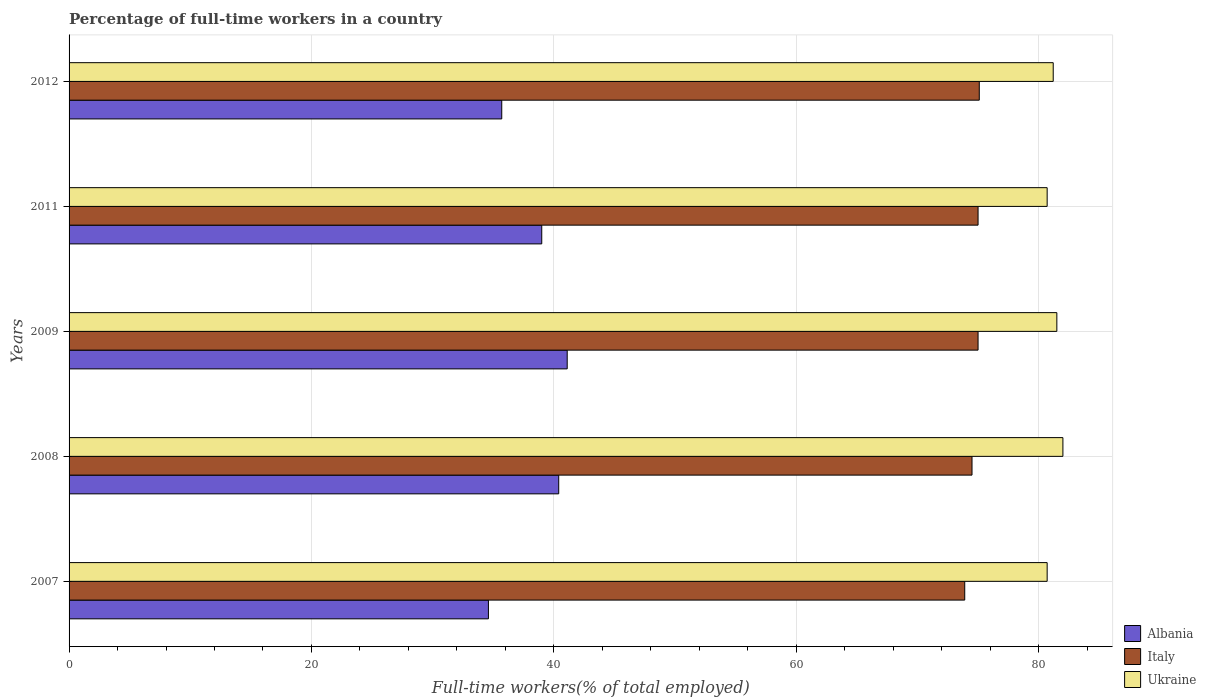How many different coloured bars are there?
Make the answer very short. 3. How many groups of bars are there?
Ensure brevity in your answer.  5. How many bars are there on the 4th tick from the top?
Provide a succinct answer. 3. What is the label of the 5th group of bars from the top?
Ensure brevity in your answer.  2007. In how many cases, is the number of bars for a given year not equal to the number of legend labels?
Provide a succinct answer. 0. What is the percentage of full-time workers in Ukraine in 2011?
Keep it short and to the point. 80.7. Across all years, what is the maximum percentage of full-time workers in Ukraine?
Give a very brief answer. 82. Across all years, what is the minimum percentage of full-time workers in Ukraine?
Ensure brevity in your answer.  80.7. What is the total percentage of full-time workers in Albania in the graph?
Your response must be concise. 190.8. What is the difference between the percentage of full-time workers in Albania in 2007 and that in 2009?
Your response must be concise. -6.5. What is the difference between the percentage of full-time workers in Italy in 2008 and the percentage of full-time workers in Ukraine in 2012?
Give a very brief answer. -6.7. What is the average percentage of full-time workers in Italy per year?
Your response must be concise. 74.7. Is the difference between the percentage of full-time workers in Italy in 2008 and 2011 greater than the difference between the percentage of full-time workers in Albania in 2008 and 2011?
Your answer should be compact. No. What is the difference between the highest and the second highest percentage of full-time workers in Albania?
Your answer should be very brief. 0.7. What is the difference between the highest and the lowest percentage of full-time workers in Ukraine?
Make the answer very short. 1.3. What does the 1st bar from the top in 2012 represents?
Give a very brief answer. Ukraine. Are all the bars in the graph horizontal?
Your response must be concise. Yes. Are the values on the major ticks of X-axis written in scientific E-notation?
Give a very brief answer. No. Does the graph contain any zero values?
Your answer should be very brief. No. Does the graph contain grids?
Your response must be concise. Yes. Where does the legend appear in the graph?
Your response must be concise. Bottom right. How are the legend labels stacked?
Your answer should be very brief. Vertical. What is the title of the graph?
Keep it short and to the point. Percentage of full-time workers in a country. What is the label or title of the X-axis?
Offer a terse response. Full-time workers(% of total employed). What is the label or title of the Y-axis?
Offer a very short reply. Years. What is the Full-time workers(% of total employed) in Albania in 2007?
Provide a short and direct response. 34.6. What is the Full-time workers(% of total employed) in Italy in 2007?
Your answer should be compact. 73.9. What is the Full-time workers(% of total employed) in Ukraine in 2007?
Offer a terse response. 80.7. What is the Full-time workers(% of total employed) of Albania in 2008?
Provide a short and direct response. 40.4. What is the Full-time workers(% of total employed) of Italy in 2008?
Ensure brevity in your answer.  74.5. What is the Full-time workers(% of total employed) of Ukraine in 2008?
Offer a terse response. 82. What is the Full-time workers(% of total employed) of Albania in 2009?
Keep it short and to the point. 41.1. What is the Full-time workers(% of total employed) of Italy in 2009?
Your answer should be compact. 75. What is the Full-time workers(% of total employed) of Ukraine in 2009?
Your response must be concise. 81.5. What is the Full-time workers(% of total employed) of Italy in 2011?
Give a very brief answer. 75. What is the Full-time workers(% of total employed) of Ukraine in 2011?
Your answer should be compact. 80.7. What is the Full-time workers(% of total employed) of Albania in 2012?
Your response must be concise. 35.7. What is the Full-time workers(% of total employed) in Italy in 2012?
Offer a very short reply. 75.1. What is the Full-time workers(% of total employed) in Ukraine in 2012?
Offer a very short reply. 81.2. Across all years, what is the maximum Full-time workers(% of total employed) in Albania?
Keep it short and to the point. 41.1. Across all years, what is the maximum Full-time workers(% of total employed) in Italy?
Your answer should be compact. 75.1. Across all years, what is the maximum Full-time workers(% of total employed) of Ukraine?
Offer a terse response. 82. Across all years, what is the minimum Full-time workers(% of total employed) of Albania?
Offer a very short reply. 34.6. Across all years, what is the minimum Full-time workers(% of total employed) of Italy?
Ensure brevity in your answer.  73.9. Across all years, what is the minimum Full-time workers(% of total employed) in Ukraine?
Offer a very short reply. 80.7. What is the total Full-time workers(% of total employed) of Albania in the graph?
Provide a short and direct response. 190.8. What is the total Full-time workers(% of total employed) in Italy in the graph?
Your response must be concise. 373.5. What is the total Full-time workers(% of total employed) of Ukraine in the graph?
Provide a short and direct response. 406.1. What is the difference between the Full-time workers(% of total employed) in Albania in 2007 and that in 2008?
Your answer should be very brief. -5.8. What is the difference between the Full-time workers(% of total employed) of Italy in 2007 and that in 2008?
Keep it short and to the point. -0.6. What is the difference between the Full-time workers(% of total employed) of Italy in 2007 and that in 2009?
Give a very brief answer. -1.1. What is the difference between the Full-time workers(% of total employed) of Ukraine in 2007 and that in 2011?
Your answer should be very brief. 0. What is the difference between the Full-time workers(% of total employed) in Albania in 2008 and that in 2009?
Offer a very short reply. -0.7. What is the difference between the Full-time workers(% of total employed) of Ukraine in 2008 and that in 2009?
Your answer should be very brief. 0.5. What is the difference between the Full-time workers(% of total employed) of Italy in 2008 and that in 2011?
Provide a succinct answer. -0.5. What is the difference between the Full-time workers(% of total employed) in Ukraine in 2008 and that in 2011?
Your response must be concise. 1.3. What is the difference between the Full-time workers(% of total employed) of Italy in 2009 and that in 2011?
Keep it short and to the point. 0. What is the difference between the Full-time workers(% of total employed) of Ukraine in 2009 and that in 2011?
Your response must be concise. 0.8. What is the difference between the Full-time workers(% of total employed) in Albania in 2009 and that in 2012?
Your answer should be very brief. 5.4. What is the difference between the Full-time workers(% of total employed) in Ukraine in 2009 and that in 2012?
Make the answer very short. 0.3. What is the difference between the Full-time workers(% of total employed) in Albania in 2007 and the Full-time workers(% of total employed) in Italy in 2008?
Offer a terse response. -39.9. What is the difference between the Full-time workers(% of total employed) in Albania in 2007 and the Full-time workers(% of total employed) in Ukraine in 2008?
Your response must be concise. -47.4. What is the difference between the Full-time workers(% of total employed) of Italy in 2007 and the Full-time workers(% of total employed) of Ukraine in 2008?
Provide a short and direct response. -8.1. What is the difference between the Full-time workers(% of total employed) in Albania in 2007 and the Full-time workers(% of total employed) in Italy in 2009?
Offer a terse response. -40.4. What is the difference between the Full-time workers(% of total employed) of Albania in 2007 and the Full-time workers(% of total employed) of Ukraine in 2009?
Offer a terse response. -46.9. What is the difference between the Full-time workers(% of total employed) in Albania in 2007 and the Full-time workers(% of total employed) in Italy in 2011?
Your response must be concise. -40.4. What is the difference between the Full-time workers(% of total employed) in Albania in 2007 and the Full-time workers(% of total employed) in Ukraine in 2011?
Ensure brevity in your answer.  -46.1. What is the difference between the Full-time workers(% of total employed) of Italy in 2007 and the Full-time workers(% of total employed) of Ukraine in 2011?
Offer a very short reply. -6.8. What is the difference between the Full-time workers(% of total employed) of Albania in 2007 and the Full-time workers(% of total employed) of Italy in 2012?
Give a very brief answer. -40.5. What is the difference between the Full-time workers(% of total employed) in Albania in 2007 and the Full-time workers(% of total employed) in Ukraine in 2012?
Offer a terse response. -46.6. What is the difference between the Full-time workers(% of total employed) in Albania in 2008 and the Full-time workers(% of total employed) in Italy in 2009?
Offer a terse response. -34.6. What is the difference between the Full-time workers(% of total employed) in Albania in 2008 and the Full-time workers(% of total employed) in Ukraine in 2009?
Your answer should be compact. -41.1. What is the difference between the Full-time workers(% of total employed) in Italy in 2008 and the Full-time workers(% of total employed) in Ukraine in 2009?
Your response must be concise. -7. What is the difference between the Full-time workers(% of total employed) in Albania in 2008 and the Full-time workers(% of total employed) in Italy in 2011?
Your response must be concise. -34.6. What is the difference between the Full-time workers(% of total employed) in Albania in 2008 and the Full-time workers(% of total employed) in Ukraine in 2011?
Make the answer very short. -40.3. What is the difference between the Full-time workers(% of total employed) of Albania in 2008 and the Full-time workers(% of total employed) of Italy in 2012?
Keep it short and to the point. -34.7. What is the difference between the Full-time workers(% of total employed) of Albania in 2008 and the Full-time workers(% of total employed) of Ukraine in 2012?
Ensure brevity in your answer.  -40.8. What is the difference between the Full-time workers(% of total employed) in Albania in 2009 and the Full-time workers(% of total employed) in Italy in 2011?
Make the answer very short. -33.9. What is the difference between the Full-time workers(% of total employed) in Albania in 2009 and the Full-time workers(% of total employed) in Ukraine in 2011?
Offer a very short reply. -39.6. What is the difference between the Full-time workers(% of total employed) in Italy in 2009 and the Full-time workers(% of total employed) in Ukraine in 2011?
Ensure brevity in your answer.  -5.7. What is the difference between the Full-time workers(% of total employed) in Albania in 2009 and the Full-time workers(% of total employed) in Italy in 2012?
Your answer should be very brief. -34. What is the difference between the Full-time workers(% of total employed) of Albania in 2009 and the Full-time workers(% of total employed) of Ukraine in 2012?
Keep it short and to the point. -40.1. What is the difference between the Full-time workers(% of total employed) in Albania in 2011 and the Full-time workers(% of total employed) in Italy in 2012?
Provide a succinct answer. -36.1. What is the difference between the Full-time workers(% of total employed) of Albania in 2011 and the Full-time workers(% of total employed) of Ukraine in 2012?
Ensure brevity in your answer.  -42.2. What is the difference between the Full-time workers(% of total employed) in Italy in 2011 and the Full-time workers(% of total employed) in Ukraine in 2012?
Keep it short and to the point. -6.2. What is the average Full-time workers(% of total employed) of Albania per year?
Offer a terse response. 38.16. What is the average Full-time workers(% of total employed) of Italy per year?
Offer a very short reply. 74.7. What is the average Full-time workers(% of total employed) of Ukraine per year?
Give a very brief answer. 81.22. In the year 2007, what is the difference between the Full-time workers(% of total employed) in Albania and Full-time workers(% of total employed) in Italy?
Your answer should be compact. -39.3. In the year 2007, what is the difference between the Full-time workers(% of total employed) in Albania and Full-time workers(% of total employed) in Ukraine?
Make the answer very short. -46.1. In the year 2008, what is the difference between the Full-time workers(% of total employed) of Albania and Full-time workers(% of total employed) of Italy?
Offer a very short reply. -34.1. In the year 2008, what is the difference between the Full-time workers(% of total employed) in Albania and Full-time workers(% of total employed) in Ukraine?
Give a very brief answer. -41.6. In the year 2008, what is the difference between the Full-time workers(% of total employed) in Italy and Full-time workers(% of total employed) in Ukraine?
Your answer should be compact. -7.5. In the year 2009, what is the difference between the Full-time workers(% of total employed) in Albania and Full-time workers(% of total employed) in Italy?
Provide a succinct answer. -33.9. In the year 2009, what is the difference between the Full-time workers(% of total employed) of Albania and Full-time workers(% of total employed) of Ukraine?
Keep it short and to the point. -40.4. In the year 2011, what is the difference between the Full-time workers(% of total employed) of Albania and Full-time workers(% of total employed) of Italy?
Your answer should be very brief. -36. In the year 2011, what is the difference between the Full-time workers(% of total employed) of Albania and Full-time workers(% of total employed) of Ukraine?
Your answer should be compact. -41.7. In the year 2011, what is the difference between the Full-time workers(% of total employed) in Italy and Full-time workers(% of total employed) in Ukraine?
Your answer should be very brief. -5.7. In the year 2012, what is the difference between the Full-time workers(% of total employed) in Albania and Full-time workers(% of total employed) in Italy?
Your answer should be compact. -39.4. In the year 2012, what is the difference between the Full-time workers(% of total employed) of Albania and Full-time workers(% of total employed) of Ukraine?
Your answer should be compact. -45.5. In the year 2012, what is the difference between the Full-time workers(% of total employed) of Italy and Full-time workers(% of total employed) of Ukraine?
Your response must be concise. -6.1. What is the ratio of the Full-time workers(% of total employed) of Albania in 2007 to that in 2008?
Keep it short and to the point. 0.86. What is the ratio of the Full-time workers(% of total employed) in Ukraine in 2007 to that in 2008?
Provide a short and direct response. 0.98. What is the ratio of the Full-time workers(% of total employed) in Albania in 2007 to that in 2009?
Keep it short and to the point. 0.84. What is the ratio of the Full-time workers(% of total employed) in Italy in 2007 to that in 2009?
Make the answer very short. 0.99. What is the ratio of the Full-time workers(% of total employed) of Ukraine in 2007 to that in 2009?
Your response must be concise. 0.99. What is the ratio of the Full-time workers(% of total employed) in Albania in 2007 to that in 2011?
Provide a succinct answer. 0.89. What is the ratio of the Full-time workers(% of total employed) of Italy in 2007 to that in 2011?
Offer a terse response. 0.99. What is the ratio of the Full-time workers(% of total employed) in Ukraine in 2007 to that in 2011?
Offer a very short reply. 1. What is the ratio of the Full-time workers(% of total employed) in Albania in 2007 to that in 2012?
Offer a terse response. 0.97. What is the ratio of the Full-time workers(% of total employed) of Italy in 2007 to that in 2012?
Your response must be concise. 0.98. What is the ratio of the Full-time workers(% of total employed) of Ukraine in 2007 to that in 2012?
Your answer should be compact. 0.99. What is the ratio of the Full-time workers(% of total employed) of Italy in 2008 to that in 2009?
Your answer should be very brief. 0.99. What is the ratio of the Full-time workers(% of total employed) of Ukraine in 2008 to that in 2009?
Offer a terse response. 1.01. What is the ratio of the Full-time workers(% of total employed) in Albania in 2008 to that in 2011?
Offer a very short reply. 1.04. What is the ratio of the Full-time workers(% of total employed) of Ukraine in 2008 to that in 2011?
Your answer should be very brief. 1.02. What is the ratio of the Full-time workers(% of total employed) in Albania in 2008 to that in 2012?
Offer a terse response. 1.13. What is the ratio of the Full-time workers(% of total employed) in Ukraine in 2008 to that in 2012?
Ensure brevity in your answer.  1.01. What is the ratio of the Full-time workers(% of total employed) in Albania in 2009 to that in 2011?
Provide a succinct answer. 1.05. What is the ratio of the Full-time workers(% of total employed) in Ukraine in 2009 to that in 2011?
Give a very brief answer. 1.01. What is the ratio of the Full-time workers(% of total employed) of Albania in 2009 to that in 2012?
Make the answer very short. 1.15. What is the ratio of the Full-time workers(% of total employed) in Ukraine in 2009 to that in 2012?
Offer a terse response. 1. What is the ratio of the Full-time workers(% of total employed) of Albania in 2011 to that in 2012?
Provide a short and direct response. 1.09. What is the ratio of the Full-time workers(% of total employed) of Ukraine in 2011 to that in 2012?
Provide a short and direct response. 0.99. What is the difference between the highest and the second highest Full-time workers(% of total employed) of Italy?
Your answer should be compact. 0.1. What is the difference between the highest and the second highest Full-time workers(% of total employed) of Ukraine?
Make the answer very short. 0.5. What is the difference between the highest and the lowest Full-time workers(% of total employed) in Albania?
Your answer should be compact. 6.5. What is the difference between the highest and the lowest Full-time workers(% of total employed) in Italy?
Offer a very short reply. 1.2. 